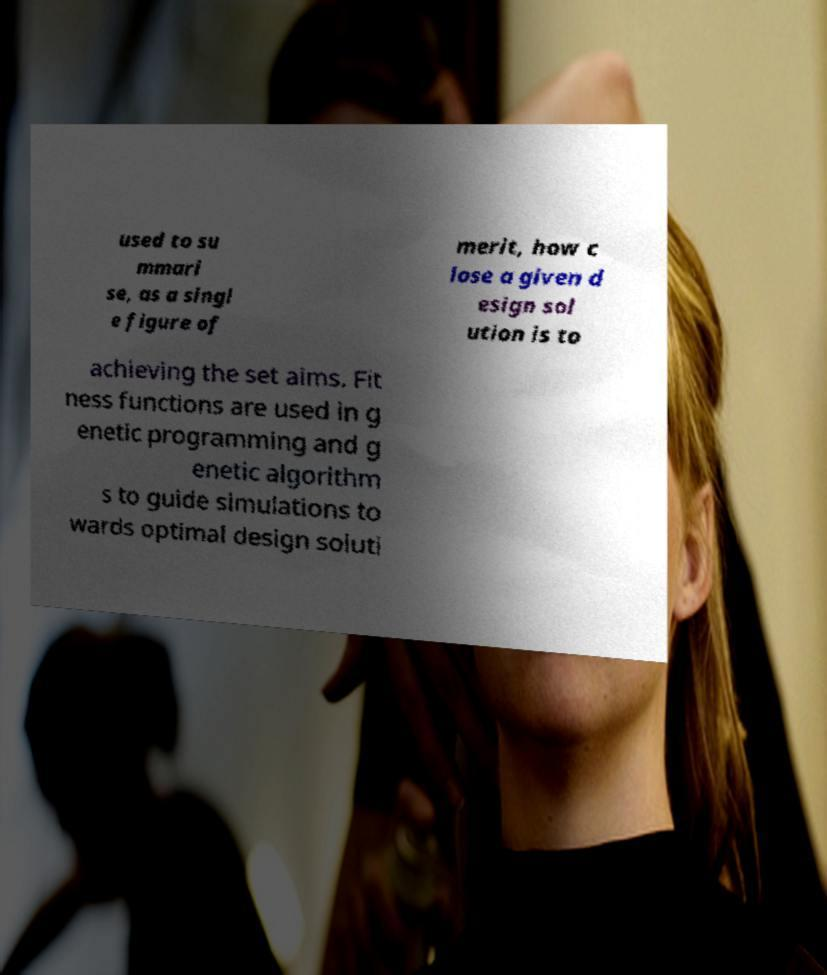Could you extract and type out the text from this image? used to su mmari se, as a singl e figure of merit, how c lose a given d esign sol ution is to achieving the set aims. Fit ness functions are used in g enetic programming and g enetic algorithm s to guide simulations to wards optimal design soluti 